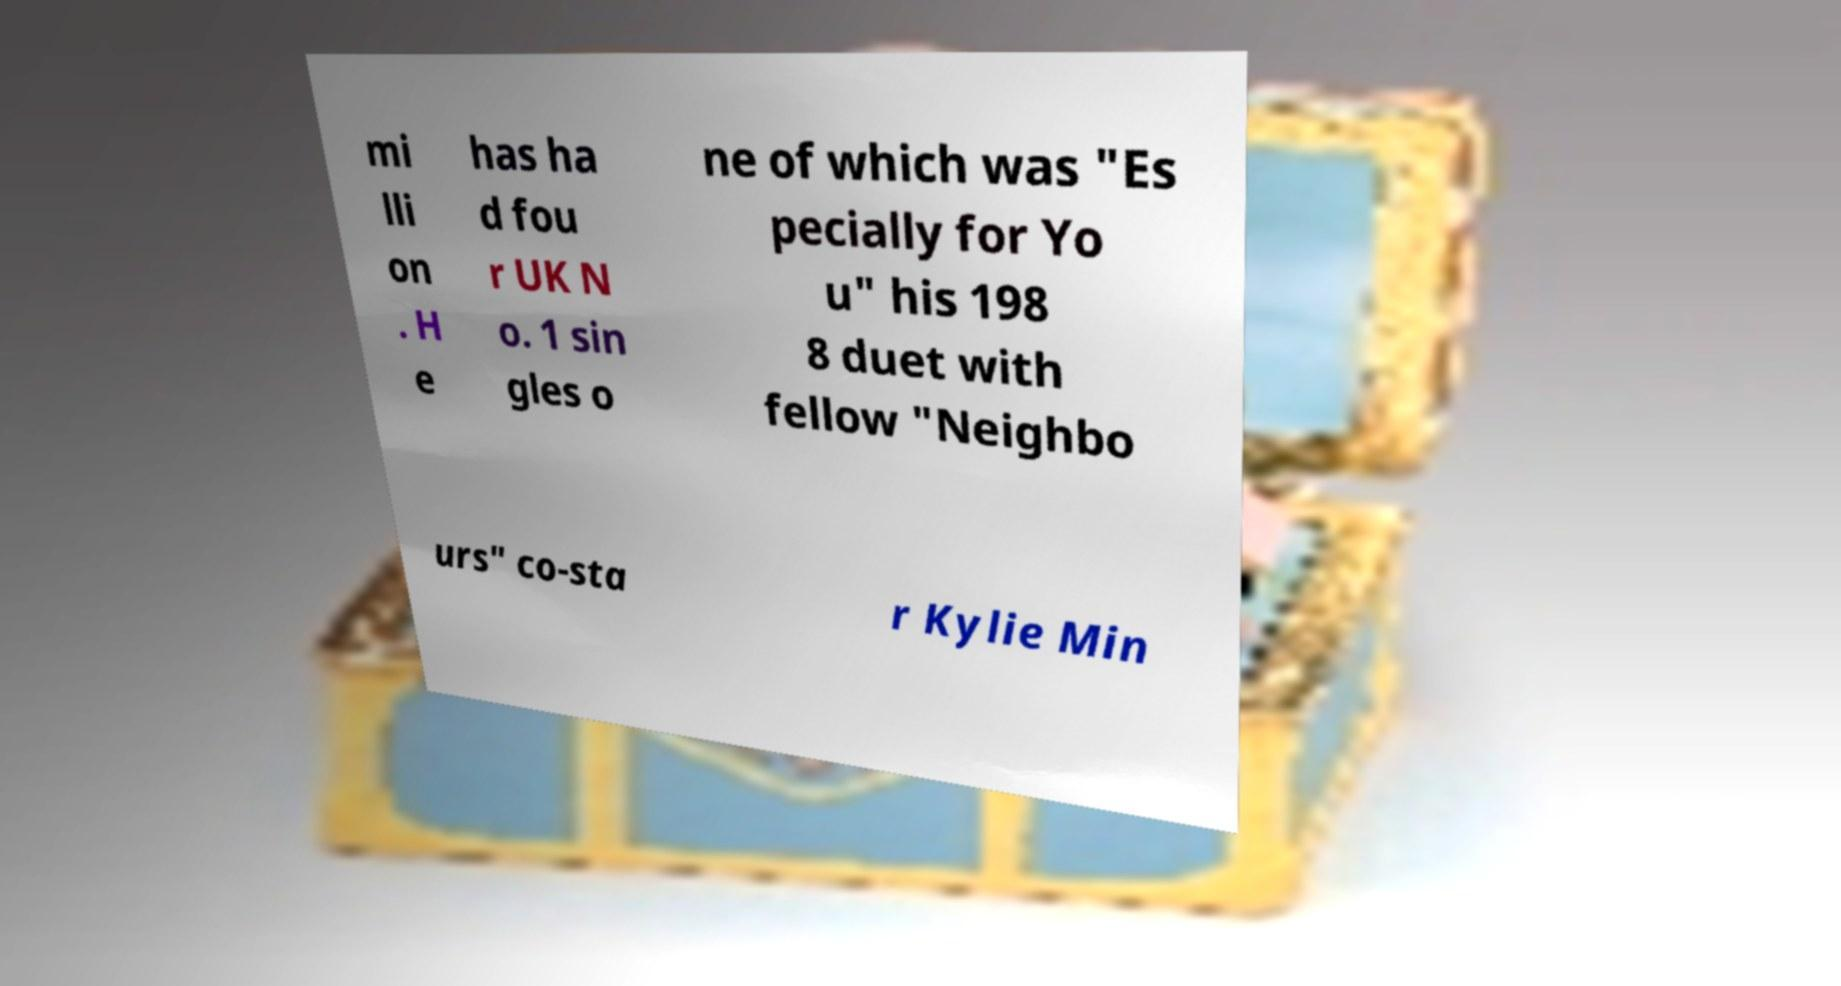For documentation purposes, I need the text within this image transcribed. Could you provide that? mi lli on . H e has ha d fou r UK N o. 1 sin gles o ne of which was "Es pecially for Yo u" his 198 8 duet with fellow "Neighbo urs" co-sta r Kylie Min 